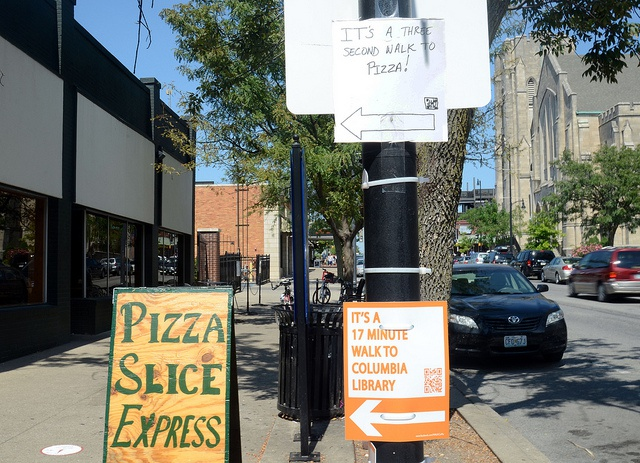Describe the objects in this image and their specific colors. I can see car in black, blue, navy, and gray tones, car in black, gray, navy, and blue tones, car in black, gray, and darkgray tones, car in black, navy, gray, and blue tones, and bicycle in black, gray, darkgray, and lightgray tones in this image. 